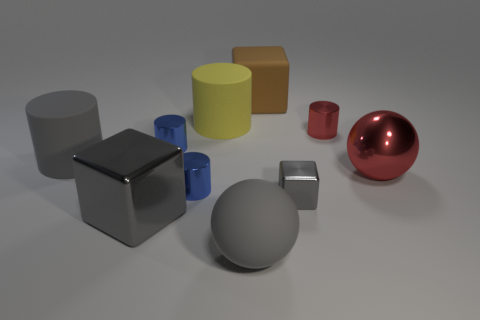Subtract all gray cylinders. How many cylinders are left? 4 Subtract 1 cylinders. How many cylinders are left? 4 Subtract all yellow cylinders. How many cylinders are left? 4 Subtract all blue blocks. Subtract all brown spheres. How many blocks are left? 3 Subtract all cubes. How many objects are left? 7 Add 4 shiny blocks. How many shiny blocks exist? 6 Subtract 0 brown balls. How many objects are left? 10 Subtract all brown cubes. Subtract all balls. How many objects are left? 7 Add 3 large gray cubes. How many large gray cubes are left? 4 